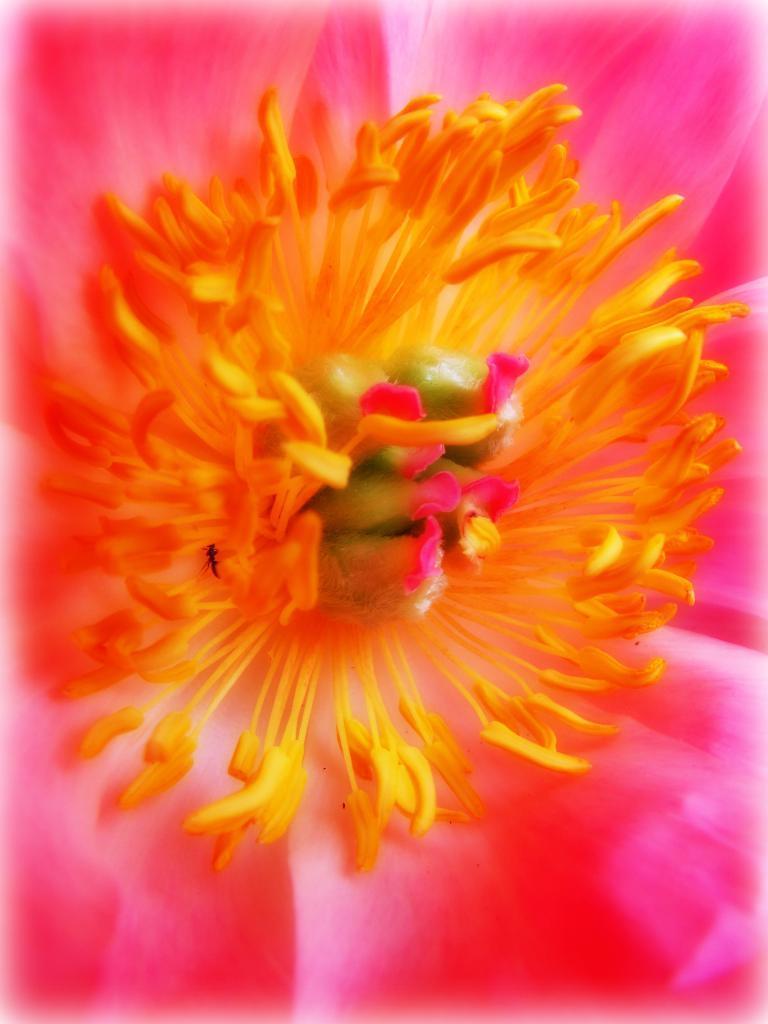Please provide a concise description of this image. In this image we can see a flower. 